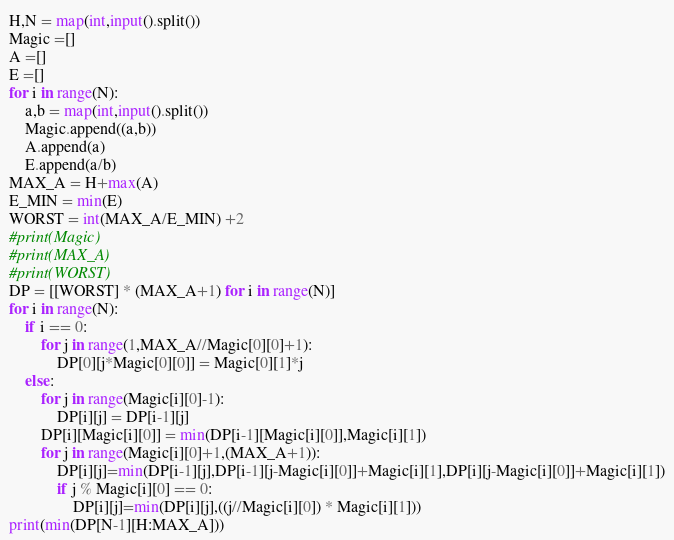<code> <loc_0><loc_0><loc_500><loc_500><_Python_>H,N = map(int,input().split())
Magic =[]
A =[]
E =[]
for i in range(N):
    a,b = map(int,input().split())
    Magic.append((a,b))
    A.append(a)
    E.append(a/b)
MAX_A = H+max(A)
E_MIN = min(E)
WORST = int(MAX_A/E_MIN) +2
#print(Magic)
#print(MAX_A)
#print(WORST)
DP = [[WORST] * (MAX_A+1) for i in range(N)]
for i in range(N):
    if i == 0:
        for j in range(1,MAX_A//Magic[0][0]+1):
            DP[0][j*Magic[0][0]] = Magic[0][1]*j
    else:
        for j in range(Magic[i][0]-1):
            DP[i][j] = DP[i-1][j]
        DP[i][Magic[i][0]] = min(DP[i-1][Magic[i][0]],Magic[i][1])
        for j in range(Magic[i][0]+1,(MAX_A+1)):
            DP[i][j]=min(DP[i-1][j],DP[i-1][j-Magic[i][0]]+Magic[i][1],DP[i][j-Magic[i][0]]+Magic[i][1])
            if j % Magic[i][0] == 0:
                DP[i][j]=min(DP[i][j],((j//Magic[i][0]) * Magic[i][1]))
print(min(DP[N-1][H:MAX_A]))</code> 